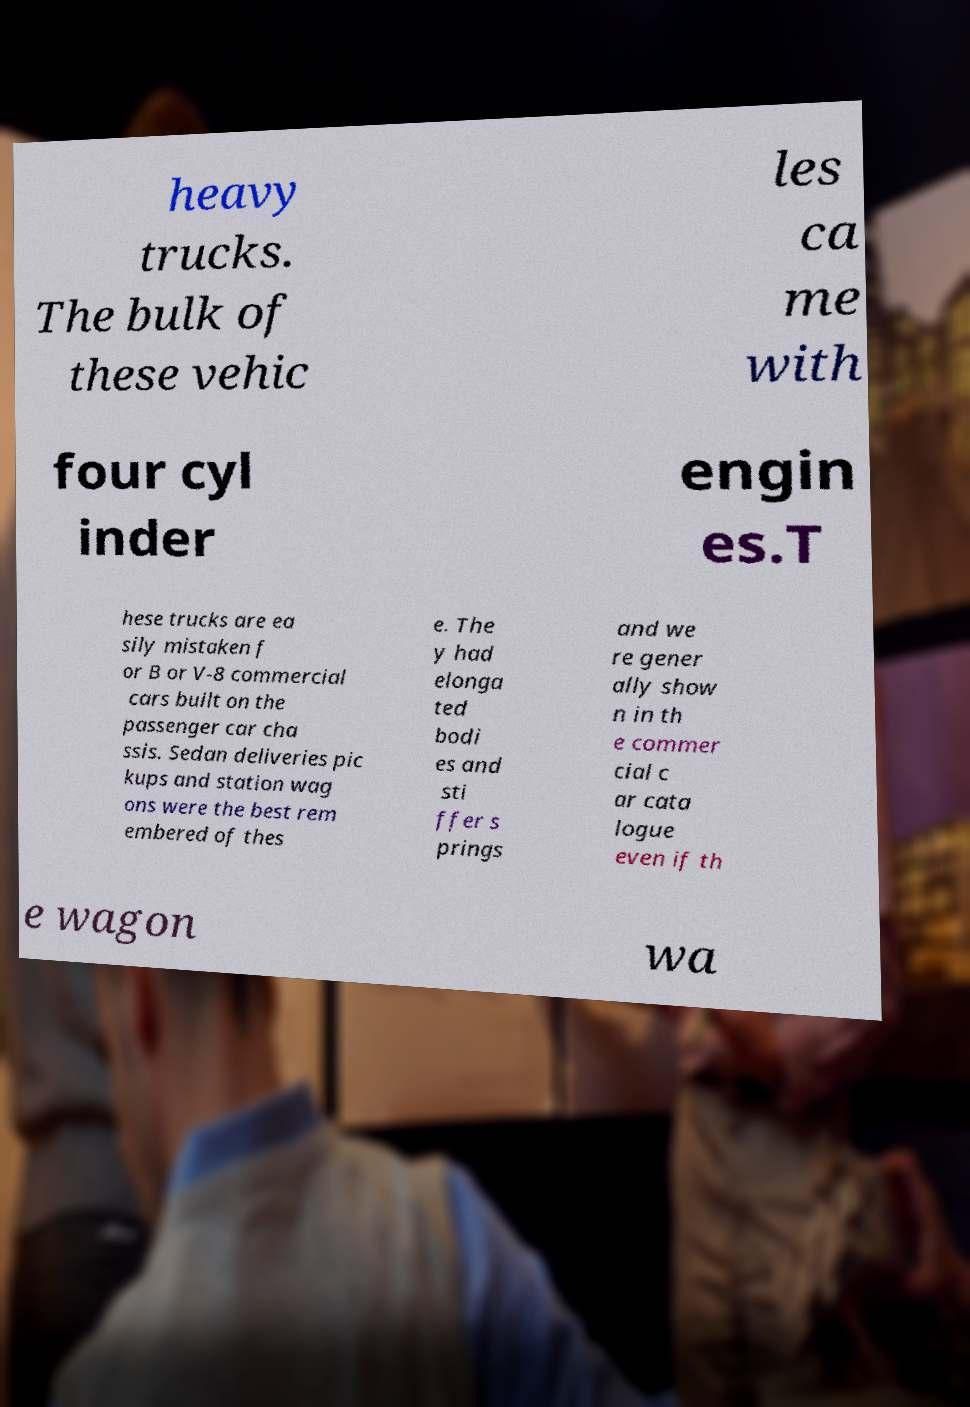There's text embedded in this image that I need extracted. Can you transcribe it verbatim? heavy trucks. The bulk of these vehic les ca me with four cyl inder engin es.T hese trucks are ea sily mistaken f or B or V-8 commercial cars built on the passenger car cha ssis. Sedan deliveries pic kups and station wag ons were the best rem embered of thes e. The y had elonga ted bodi es and sti ffer s prings and we re gener ally show n in th e commer cial c ar cata logue even if th e wagon wa 